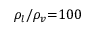<formula> <loc_0><loc_0><loc_500><loc_500>{ \rho _ { l } } / { \rho _ { v } } { = } 1 0 0</formula> 